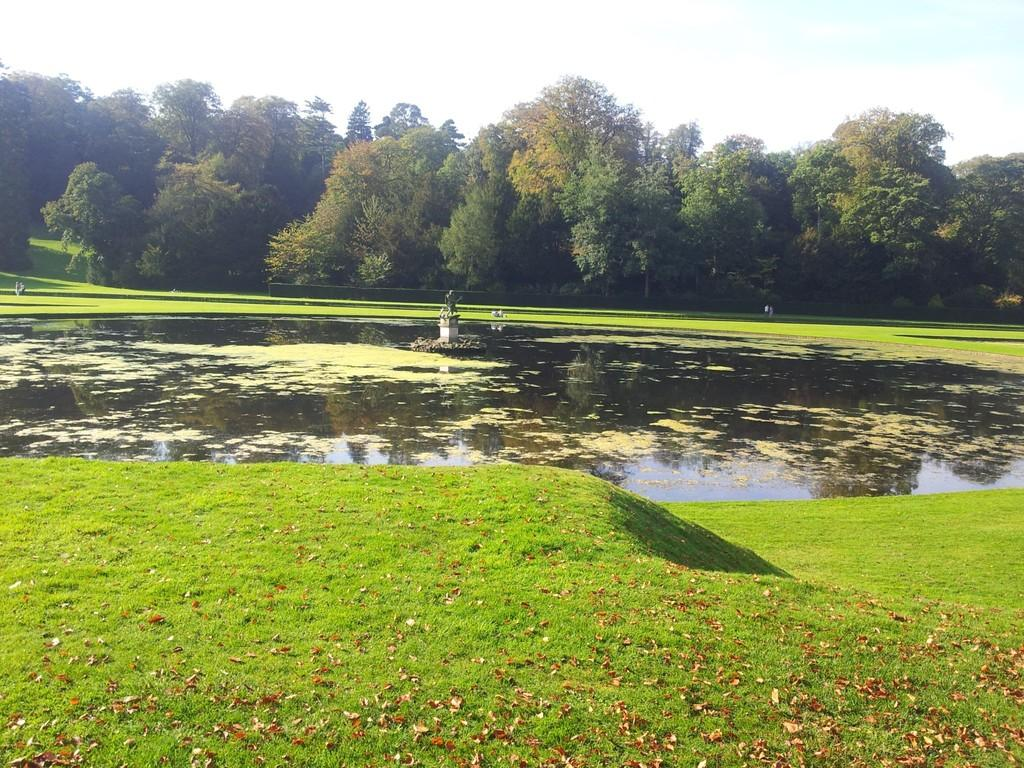What is the main subject of the image? There is a statue in the image. What is the statue situated in? The statue is in water. What can be observed in the water? Algae are present in the water. What type of vegetation is visible in the image? There is grass visible in the image. What can be seen in the background of the image? There are trees and the sky visible in the background of the image. What type of government is depicted in the statue in the image? The statue does not depict a government; it is a standalone statue. How many kittens are playing around the statue in the image? There are no kittens present in the image. 